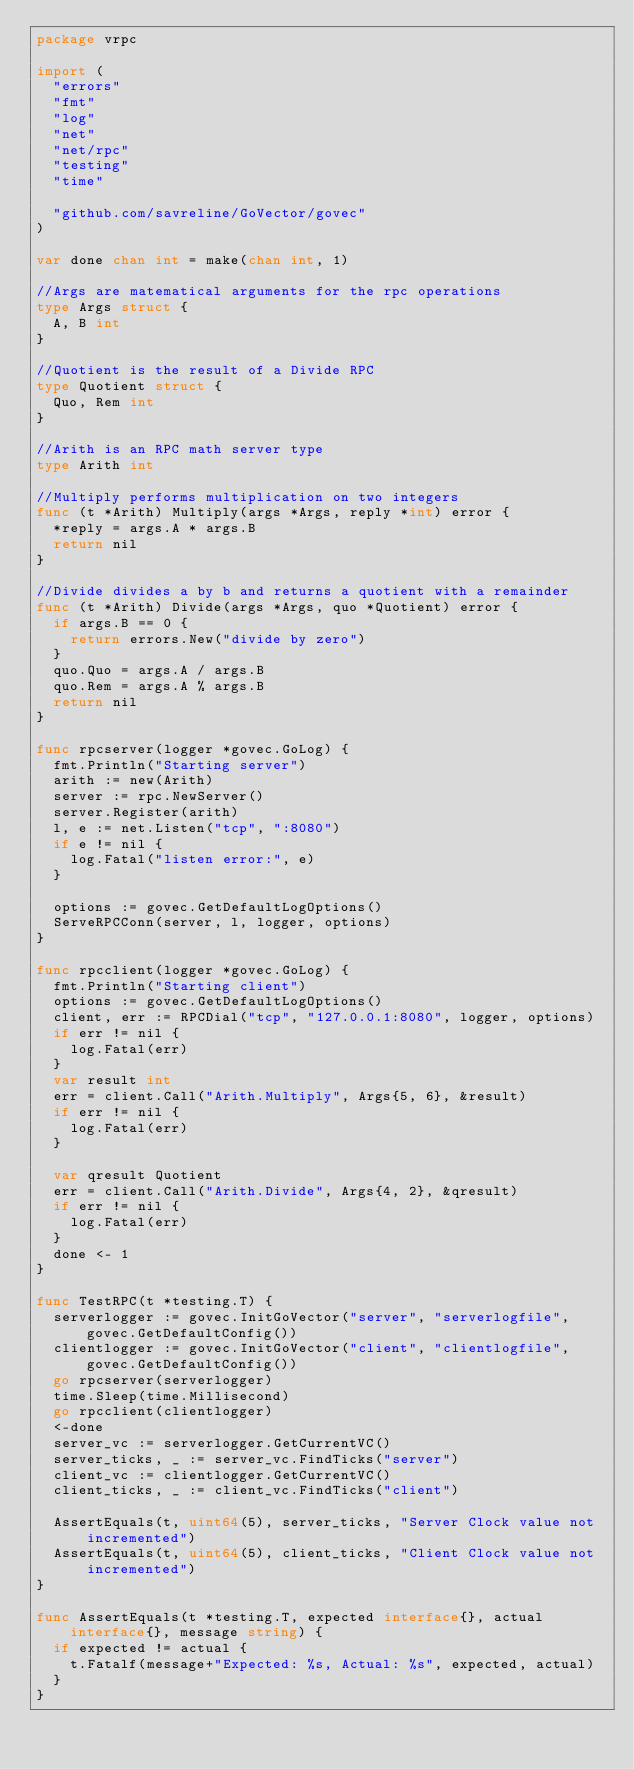<code> <loc_0><loc_0><loc_500><loc_500><_Go_>package vrpc

import (
	"errors"
	"fmt"
	"log"
	"net"
	"net/rpc"
	"testing"
	"time"

	"github.com/savreline/GoVector/govec"
)

var done chan int = make(chan int, 1)

//Args are matematical arguments for the rpc operations
type Args struct {
	A, B int
}

//Quotient is the result of a Divide RPC
type Quotient struct {
	Quo, Rem int
}

//Arith is an RPC math server type
type Arith int

//Multiply performs multiplication on two integers
func (t *Arith) Multiply(args *Args, reply *int) error {
	*reply = args.A * args.B
	return nil
}

//Divide divides a by b and returns a quotient with a remainder
func (t *Arith) Divide(args *Args, quo *Quotient) error {
	if args.B == 0 {
		return errors.New("divide by zero")
	}
	quo.Quo = args.A / args.B
	quo.Rem = args.A % args.B
	return nil
}

func rpcserver(logger *govec.GoLog) {
	fmt.Println("Starting server")
	arith := new(Arith)
	server := rpc.NewServer()
	server.Register(arith)
	l, e := net.Listen("tcp", ":8080")
	if e != nil {
		log.Fatal("listen error:", e)
	}

	options := govec.GetDefaultLogOptions()
	ServeRPCConn(server, l, logger, options)
}

func rpcclient(logger *govec.GoLog) {
	fmt.Println("Starting client")
	options := govec.GetDefaultLogOptions()
	client, err := RPCDial("tcp", "127.0.0.1:8080", logger, options)
	if err != nil {
		log.Fatal(err)
	}
	var result int
	err = client.Call("Arith.Multiply", Args{5, 6}, &result)
	if err != nil {
		log.Fatal(err)
	}

	var qresult Quotient
	err = client.Call("Arith.Divide", Args{4, 2}, &qresult)
	if err != nil {
		log.Fatal(err)
	}
	done <- 1
}

func TestRPC(t *testing.T) {
	serverlogger := govec.InitGoVector("server", "serverlogfile", govec.GetDefaultConfig())
	clientlogger := govec.InitGoVector("client", "clientlogfile", govec.GetDefaultConfig())
	go rpcserver(serverlogger)
	time.Sleep(time.Millisecond)
	go rpcclient(clientlogger)
	<-done
	server_vc := serverlogger.GetCurrentVC()
	server_ticks, _ := server_vc.FindTicks("server")
	client_vc := clientlogger.GetCurrentVC()
	client_ticks, _ := client_vc.FindTicks("client")

	AssertEquals(t, uint64(5), server_ticks, "Server Clock value not incremented")
	AssertEquals(t, uint64(5), client_ticks, "Client Clock value not incremented")
}

func AssertEquals(t *testing.T, expected interface{}, actual interface{}, message string) {
	if expected != actual {
		t.Fatalf(message+"Expected: %s, Actual: %s", expected, actual)
	}
}
</code> 